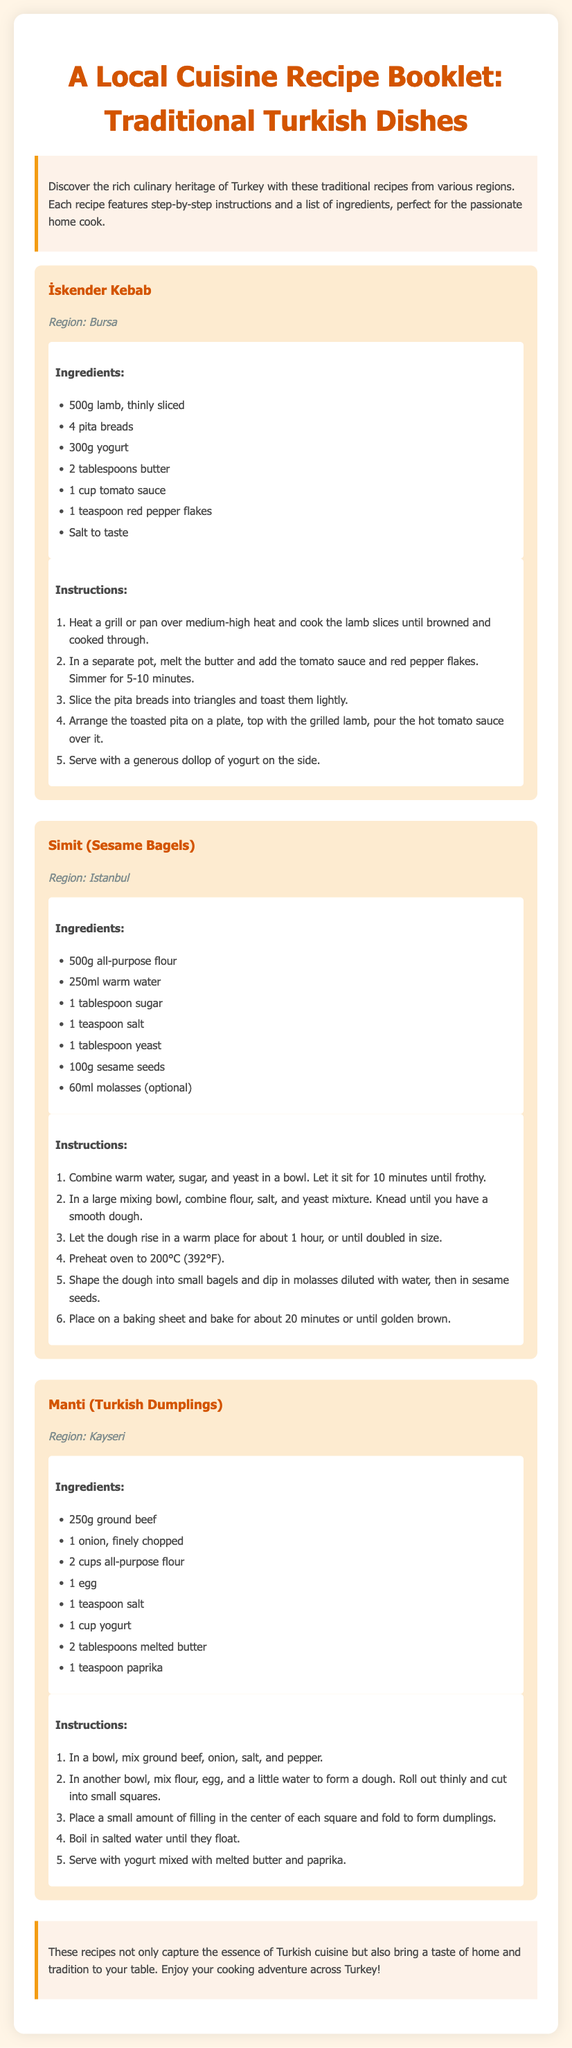What is the title of the booklet? The title is prominently displayed at the top of the document as "A Local Cuisine Recipe Booklet: Traditional Turkish Dishes."
Answer: A Local Cuisine Recipe Booklet: Traditional Turkish Dishes How many recipes are included in the document? The document features three distinct recipes for traditional Turkish dishes.
Answer: Three What region is İskender Kebab from? The recipe for İskender Kebab includes a specific region mentioned within its description.
Answer: Bursa What is one optional ingredient for Simit? The ingredients section for Simit lists an option for an ingredient, which indicates it's not mandatory.
Answer: Molasses What should you serve Manti with? The instructions for Manti highlight a specific accompaniment for serving the dish.
Answer: Yogurt mixed with melted butter and paprika What is the main protein used in Manti? Manti's ingredient list specifies the type of meat used for the filling in the dumplings.
Answer: Ground beef In what type of cooking vessel should you prepare İskender Kebab? The cooking method described for İskender Kebab mentions using a specific type of cooking vessel.
Answer: Grill or pan How long should the dough for Simit rise? The instructions for making Simit specify the time needed for the dough to rise for optimal results.
Answer: 1 hour 